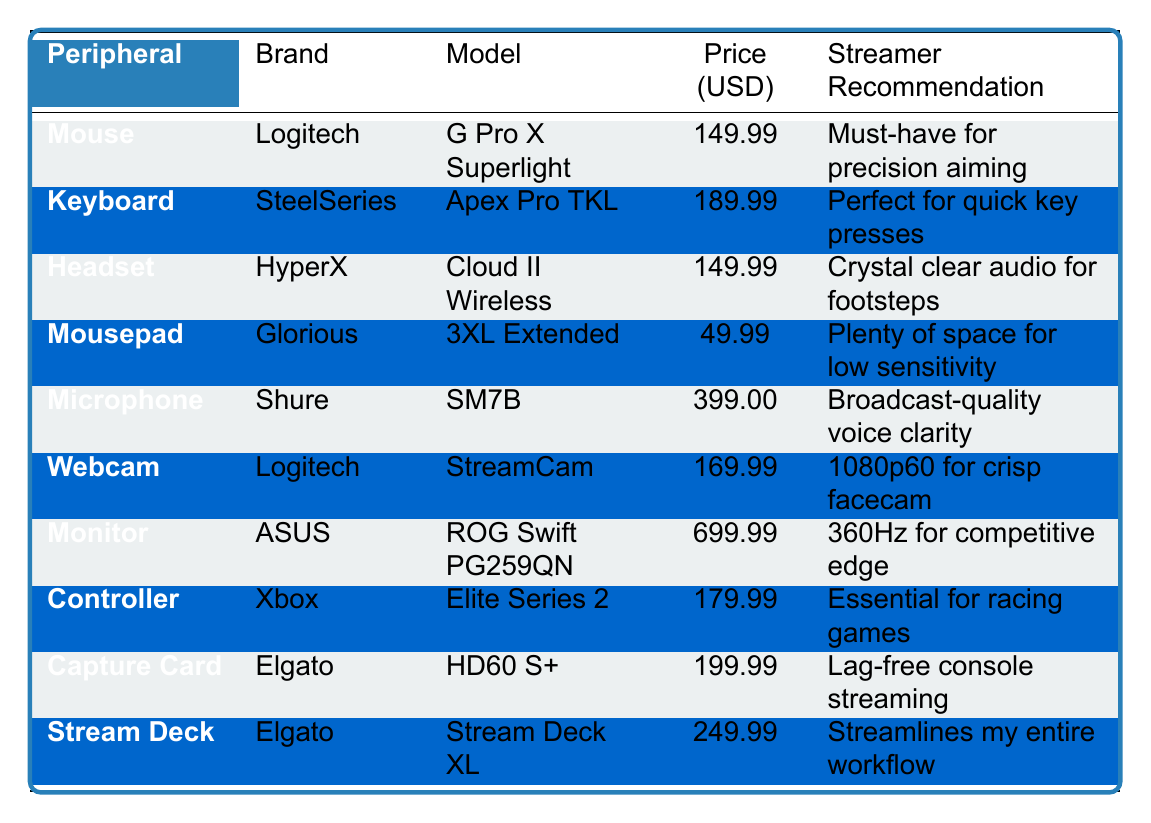What is the price of the Logitech G Pro X Superlight mouse? The price listed for the Logitech G Pro X Superlight mouse in the table is 149.99 USD.
Answer: 149.99 Which headset has the same price as the Logitech G Pro X Superlight? The table shows that the HyperX Cloud II Wireless headset also costs 149.99 USD, which is the same price as the Logitech G Pro X Superlight mouse.
Answer: HyperX Cloud II Wireless Is the SteelSeries Apex Pro TKL keyboard more expensive than the Xbox Elite Series 2 controller? The SteelSeries Apex Pro TKL keyboard costs 189.99 USD, while the Xbox Elite Series 2 controller is priced at 179.99 USD. Since 189.99 is greater than 179.99, the statement is true.
Answer: Yes What is the total price of the headset and the mouse combined? The price of the HyperX Cloud II Wireless headset is 149.99 USD, and the price of the Logitech G Pro X Superlight mouse is also 149.99 USD. Adding them together gives 149.99 + 149.99 = 299.98 USD.
Answer: 299.98 Which peripheral is the most expensive according to the table? Looking through the prices of each peripheral, the Shure SM7B microphone at 399.00 USD is listed as the most expensive item.
Answer: Shure SM7B What is the average price of all the peripherals listed in the table? The total price of all the peripherals is 149.99 + 189.99 + 149.99 + 49.99 + 399.00 + 169.99 + 699.99 + 179.99 + 199.99 + 249.99 = 2279.92 USD. There are 10 peripherals, so the average price is 2279.92 / 10 = 227.99 USD.
Answer: 227.99 Are all peripherals recommended by the streamer? The table contains recommendations for each peripheral, indicating they are all recommended by the streamer. Therefore, the answer is true.
Answer: Yes How much more does the ASUS ROG Swift PG259QN monitor cost compared to the Glorious 3XL Extended mousepad? The ASUS ROG Swift PG259QN monitor costs 699.99 USD, while the Glorious 3XL Extended mousepad costs 49.99 USD. The difference is calculated as 699.99 - 49.99 = 650.00 USD.
Answer: 650.00 Which peripheral has the recommendation related to broadcasting? The Shure SM7B microphone is recommended for its broadcast-quality voice clarity, which refers to broadcasting.
Answer: Shure SM7B What percentage of the peripherals cost over 200 USD? The peripherals over 200 USD are the Shure SM7B microphone (399.00 USD), ASUS ROG Swift PG259QN monitor (699.99 USD), and Elgato Stream Deck XL (249.99 USD) making a total of 3 out of 10 peripherals. The percentage is (3/10) * 100 = 30%.
Answer: 30% What is the lowest-priced peripheral recommended for low sensitivity use? The Glorious 3XL Extended mousepad is priced at 49.99 USD and is specifically recommended for low sensitivity use.
Answer: Glorious 3XL Extended 